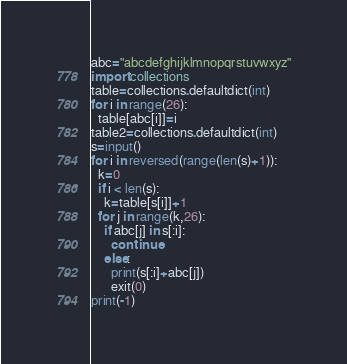Convert code to text. <code><loc_0><loc_0><loc_500><loc_500><_Python_>abc="abcdefghijklmnopqrstuvwxyz"
import collections
table=collections.defaultdict(int)
for i in range(26):
  table[abc[i]]=i
table2=collections.defaultdict(int)
s=input()
for i in reversed(range(len(s)+1)):
  k=0
  if i < len(s):
    k=table[s[i]]+1
  for j in range(k,26):
    if abc[j] in s[:i]:
      continue
    else:
      print(s[:i]+abc[j])
      exit(0)
print(-1)</code> 